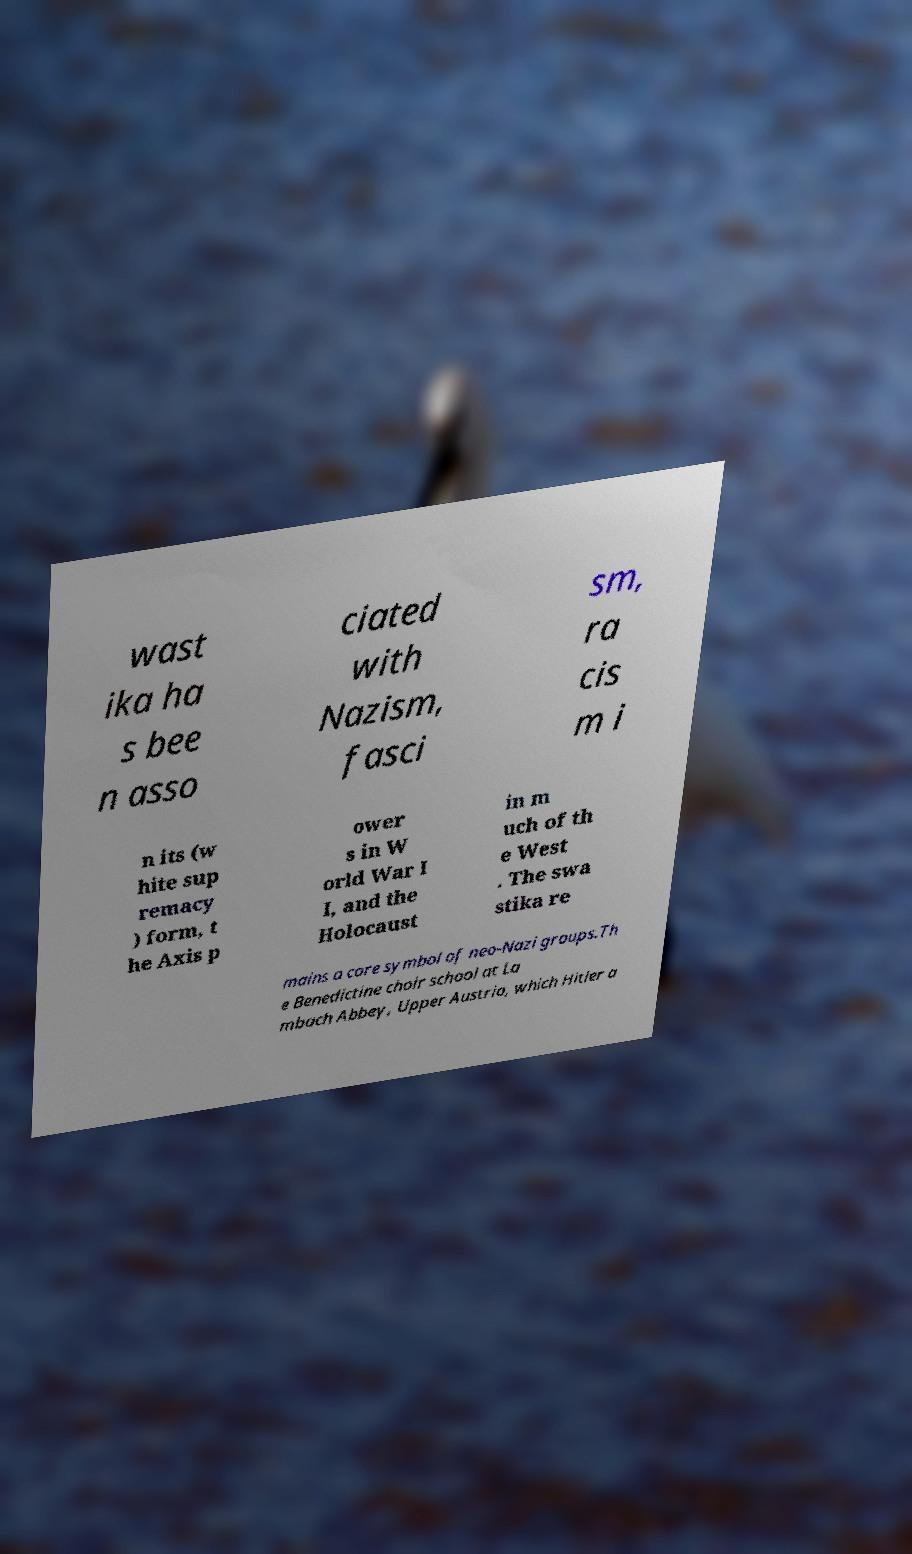Please identify and transcribe the text found in this image. wast ika ha s bee n asso ciated with Nazism, fasci sm, ra cis m i n its (w hite sup remacy ) form, t he Axis p ower s in W orld War I I, and the Holocaust in m uch of th e West . The swa stika re mains a core symbol of neo-Nazi groups.Th e Benedictine choir school at La mbach Abbey, Upper Austria, which Hitler a 